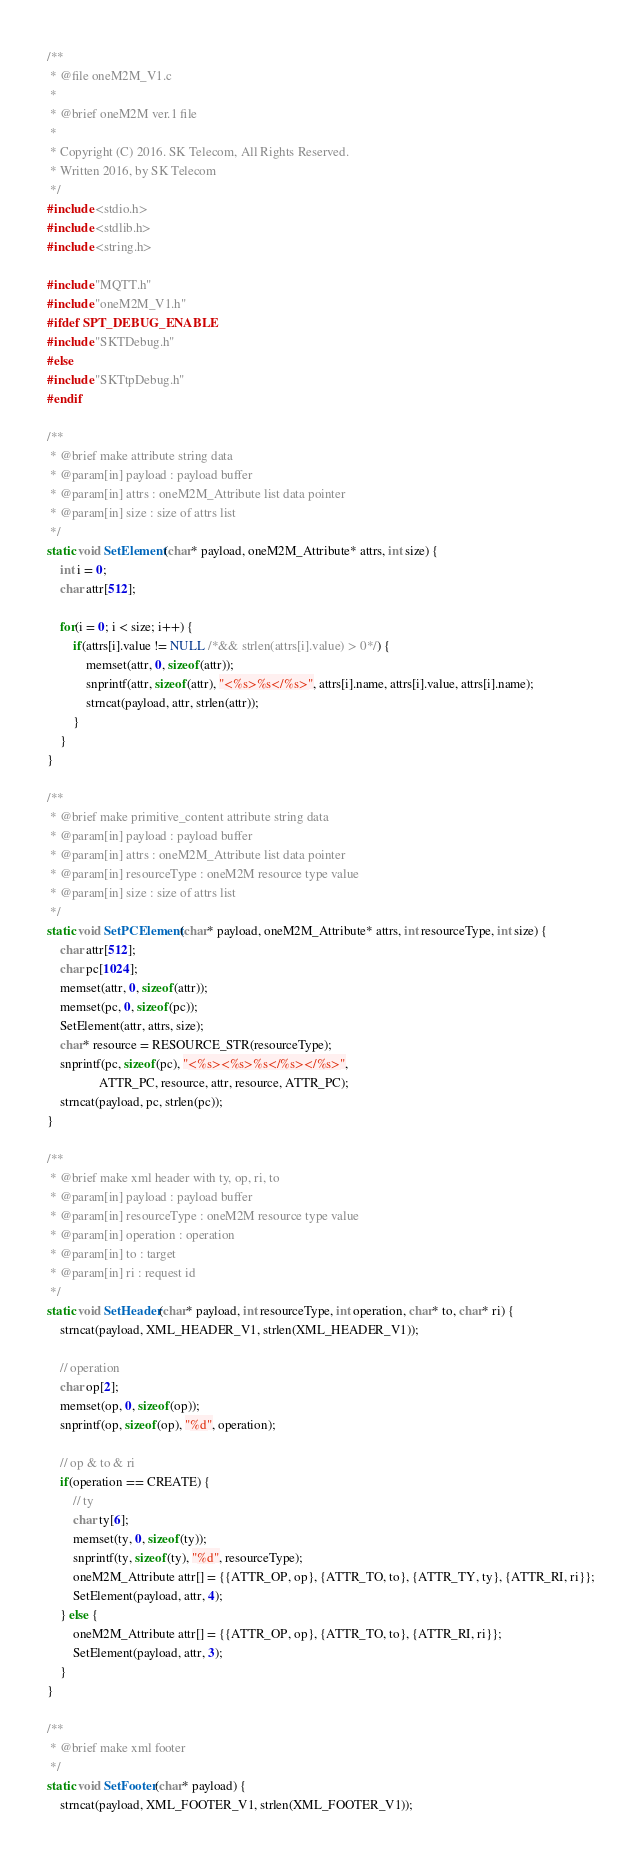<code> <loc_0><loc_0><loc_500><loc_500><_C_>/**
 * @file oneM2M_V1.c
 *
 * @brief oneM2M ver.1 file
 *
 * Copyright (C) 2016. SK Telecom, All Rights Reserved.
 * Written 2016, by SK Telecom
 */
#include <stdio.h>
#include <stdlib.h>
#include <string.h>

#include "MQTT.h"
#include "oneM2M_V1.h"
#ifdef SPT_DEBUG_ENABLE
#include "SKTDebug.h"
#else
#include "SKTtpDebug.h"
#endif

/**
 * @brief make attribute string data
 * @param[in] payload : payload buffer
 * @param[in] attrs : oneM2M_Attribute list data pointer
 * @param[in] size : size of attrs list
 */
static void SetElement(char* payload, oneM2M_Attribute* attrs, int size) {
    int i = 0;
    char attr[512];
 
    for(i = 0; i < size; i++) {
        if(attrs[i].value != NULL /*&& strlen(attrs[i].value) > 0*/) {
            memset(attr, 0, sizeof(attr));
            snprintf(attr, sizeof(attr), "<%s>%s</%s>", attrs[i].name, attrs[i].value, attrs[i].name);
            strncat(payload, attr, strlen(attr));
        }
    }
}

/**
 * @brief make primitive_content attribute string data
 * @param[in] payload : payload buffer
 * @param[in] attrs : oneM2M_Attribute list data pointer
 * @param[in] resourceType : oneM2M resource type value
 * @param[in] size : size of attrs list
 */
static void SetPCElement(char* payload, oneM2M_Attribute* attrs, int resourceType, int size) {
    char attr[512];
    char pc[1024];
    memset(attr, 0, sizeof(attr));
    memset(pc, 0, sizeof(pc));
    SetElement(attr, attrs, size);
    char* resource = RESOURCE_STR(resourceType);
    snprintf(pc, sizeof(pc), "<%s><%s>%s</%s></%s>", 
                ATTR_PC, resource, attr, resource, ATTR_PC);
    strncat(payload, pc, strlen(pc));
}

/**
 * @brief make xml header with ty, op, ri, to
 * @param[in] payload : payload buffer
 * @param[in] resourceType : oneM2M resource type value
 * @param[in] operation : operation
 * @param[in] to : target
 * @param[in] ri : request id
 */
static void SetHeader(char* payload, int resourceType, int operation, char* to, char* ri) {
    strncat(payload, XML_HEADER_V1, strlen(XML_HEADER_V1));

    // operation
    char op[2];
    memset(op, 0, sizeof(op));
    snprintf(op, sizeof(op), "%d", operation);

    // op & to & ri
    if(operation == CREATE) {        
        // ty
        char ty[6];
        memset(ty, 0, sizeof(ty));
        snprintf(ty, sizeof(ty), "%d", resourceType);
        oneM2M_Attribute attr[] = {{ATTR_OP, op}, {ATTR_TO, to}, {ATTR_TY, ty}, {ATTR_RI, ri}};
        SetElement(payload, attr, 4);
    } else {
        oneM2M_Attribute attr[] = {{ATTR_OP, op}, {ATTR_TO, to}, {ATTR_RI, ri}};
        SetElement(payload, attr, 3);
    }
}

/**
 * @brief make xml footer
 */
static void SetFooter(char* payload) {
    strncat(payload, XML_FOOTER_V1, strlen(XML_FOOTER_V1));</code> 